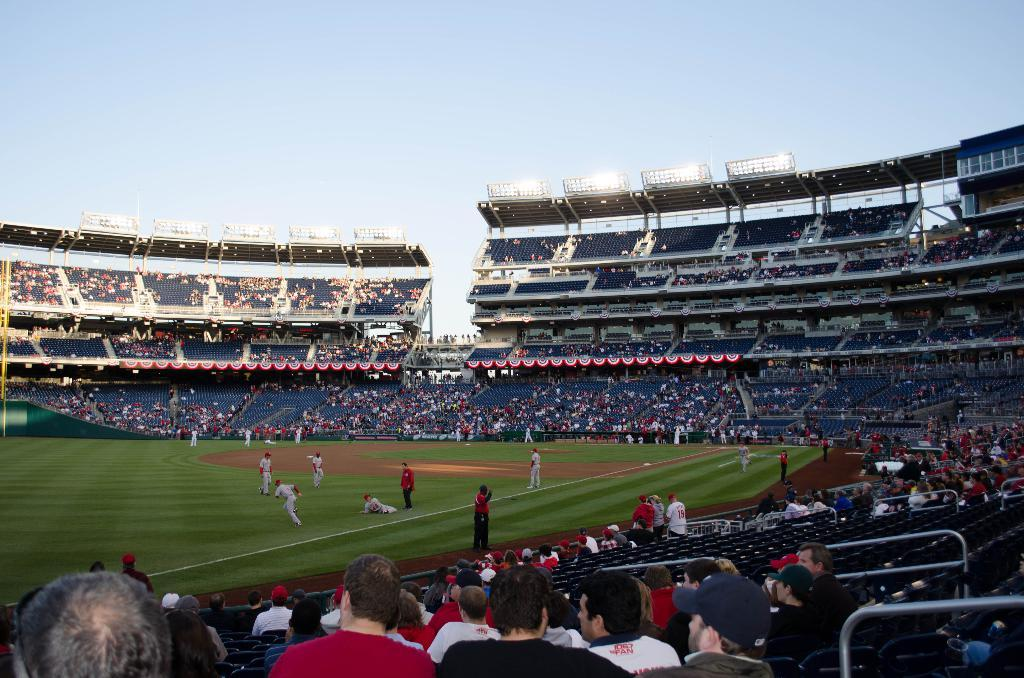What type of venue is depicted in the image? There is a stadium in the image. What are the people in the stadium doing? The people are sitting and standing in the stadium, and some are playing baseball in the middle of the image. What can be seen at the top of the image? The sky is visible at the top of the image. What songs are being sung by the people in the stadium during the feast? There is no mention of a feast or songs being sung in the image. The image depicts a baseball game taking place in a stadium. 